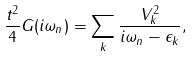<formula> <loc_0><loc_0><loc_500><loc_500>\frac { t ^ { 2 } } { 4 } G ( i \omega _ { n } ) = \sum _ { k } \frac { V _ { k } ^ { 2 } } { i \omega _ { n } - \epsilon _ { k } } ,</formula> 